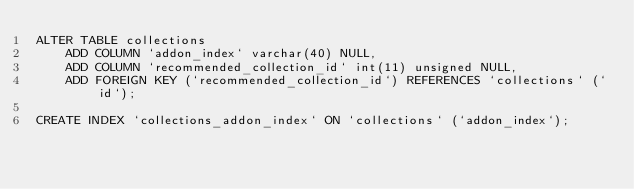Convert code to text. <code><loc_0><loc_0><loc_500><loc_500><_SQL_>ALTER TABLE collections
    ADD COLUMN `addon_index` varchar(40) NULL,
    ADD COLUMN `recommended_collection_id` int(11) unsigned NULL,
    ADD FOREIGN KEY (`recommended_collection_id`) REFERENCES `collections` (`id`);

CREATE INDEX `collections_addon_index` ON `collections` (`addon_index`);
</code> 